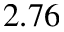Convert formula to latex. <formula><loc_0><loc_0><loc_500><loc_500>2 . 7 6</formula> 